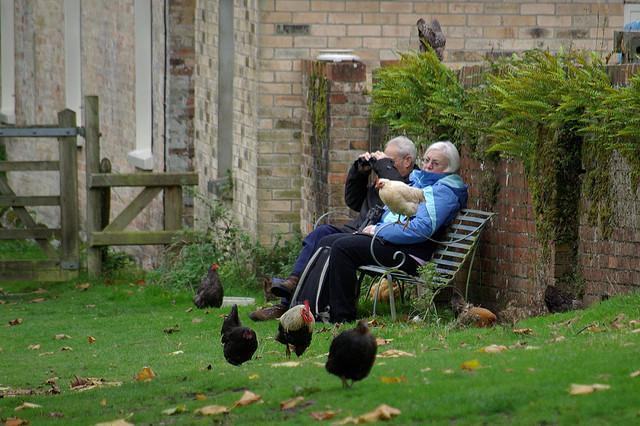How many people are in the picture?
Give a very brief answer. 2. 